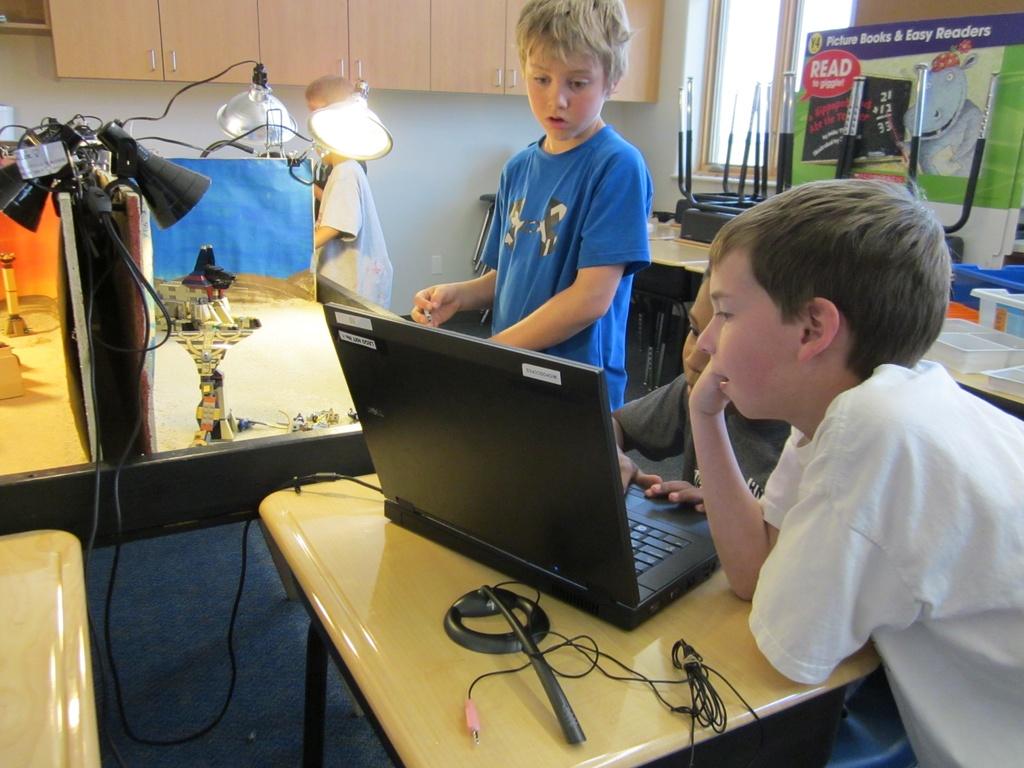What kind of books are shown in the back of the room?
Provide a short and direct response. Picture books. What is the math problem on the poster?
Your response must be concise. 21+12=33. 